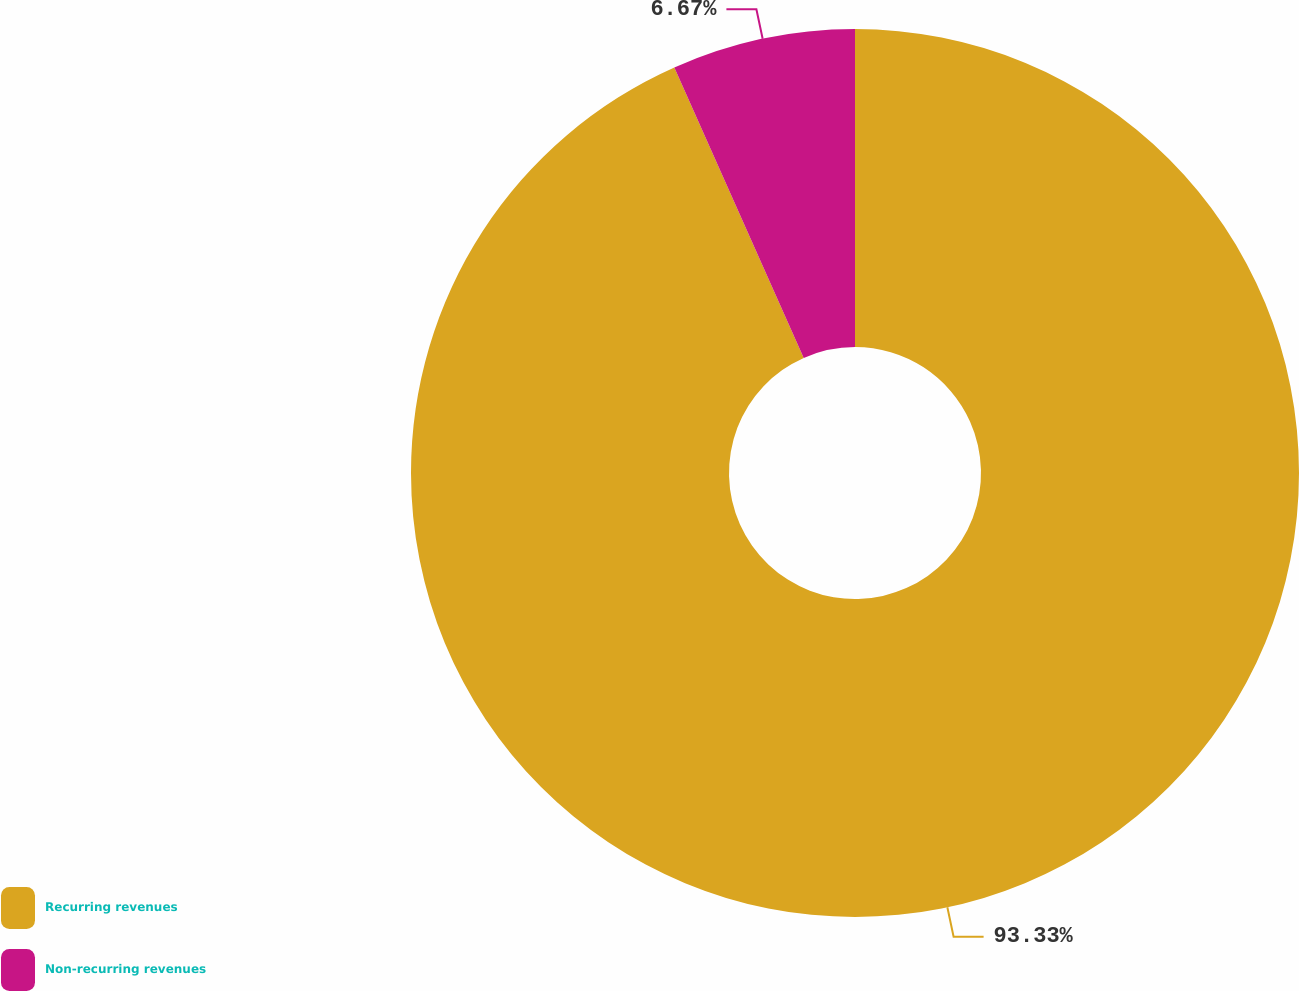<chart> <loc_0><loc_0><loc_500><loc_500><pie_chart><fcel>Recurring revenues<fcel>Non-recurring revenues<nl><fcel>93.33%<fcel>6.67%<nl></chart> 